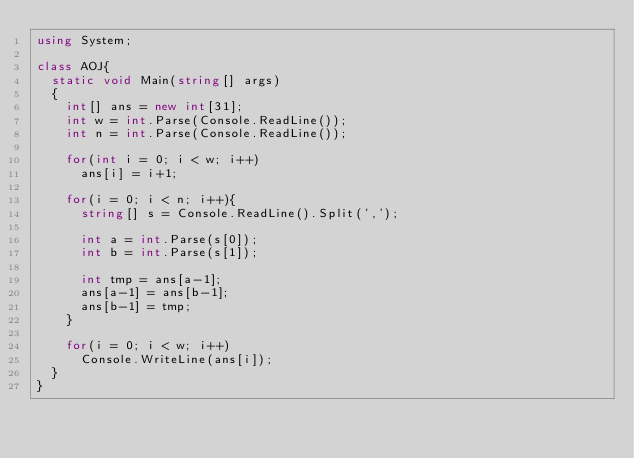Convert code to text. <code><loc_0><loc_0><loc_500><loc_500><_C#_>using System;

class AOJ{
  static void Main(string[] args)
  {
    int[] ans = new int[31];
    int w = int.Parse(Console.ReadLine());
    int n = int.Parse(Console.ReadLine());

    for(int i = 0; i < w; i++)
      ans[i] = i+1;

    for(i = 0; i < n; i++){
      string[] s = Console.ReadLine().Split(',');

      int a = int.Parse(s[0]);
      int b = int.Parse(s[1]);

      int tmp = ans[a-1];
      ans[a-1] = ans[b-1];
      ans[b-1] = tmp;
    }

    for(i = 0; i < w; i++)
      Console.WriteLine(ans[i]);
  }
}</code> 